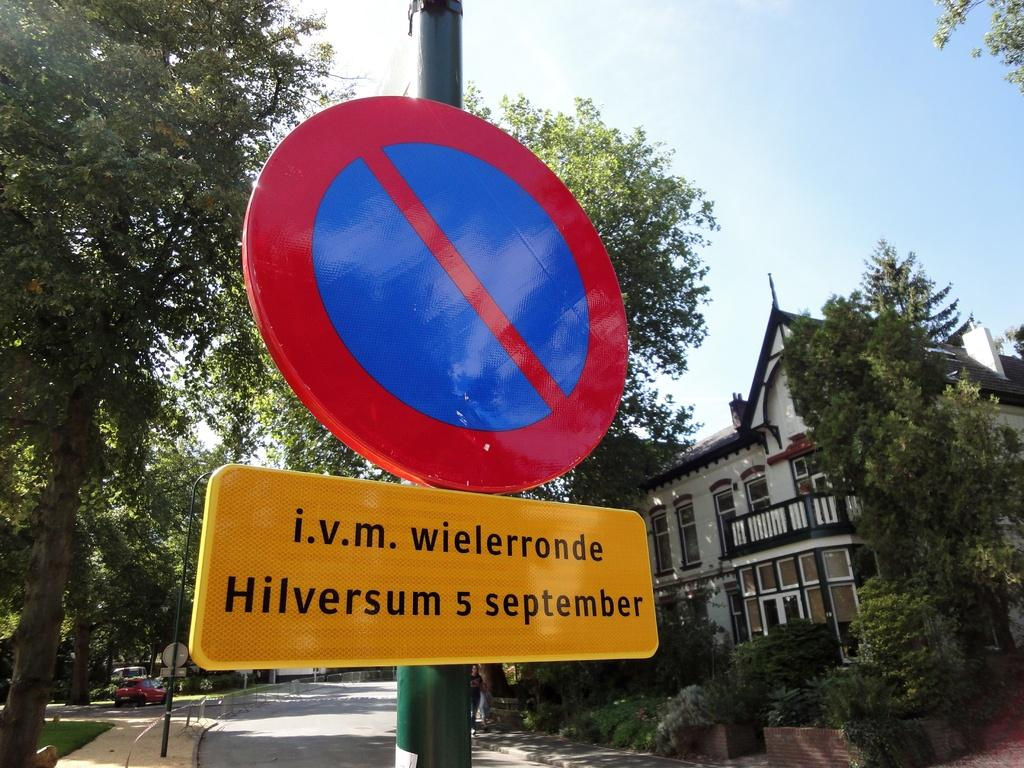Provide a one-sentence caption for the provided image. A do not enter sign with the words i.v.m wielerronde Hilversum s september. 